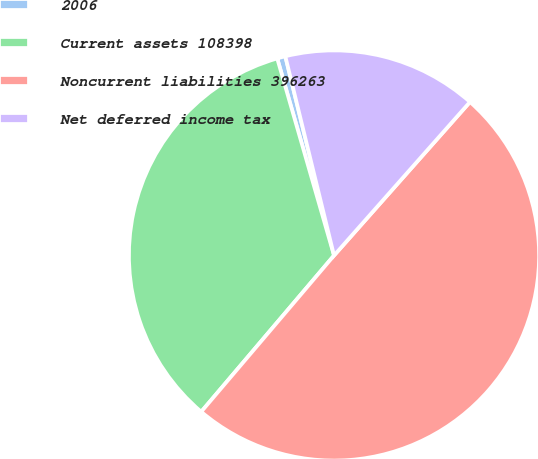Convert chart to OTSL. <chart><loc_0><loc_0><loc_500><loc_500><pie_chart><fcel>2006<fcel>Current assets 108398<fcel>Noncurrent liabilities 396263<fcel>Net deferred income tax<nl><fcel>0.65%<fcel>34.32%<fcel>49.67%<fcel>15.35%<nl></chart> 